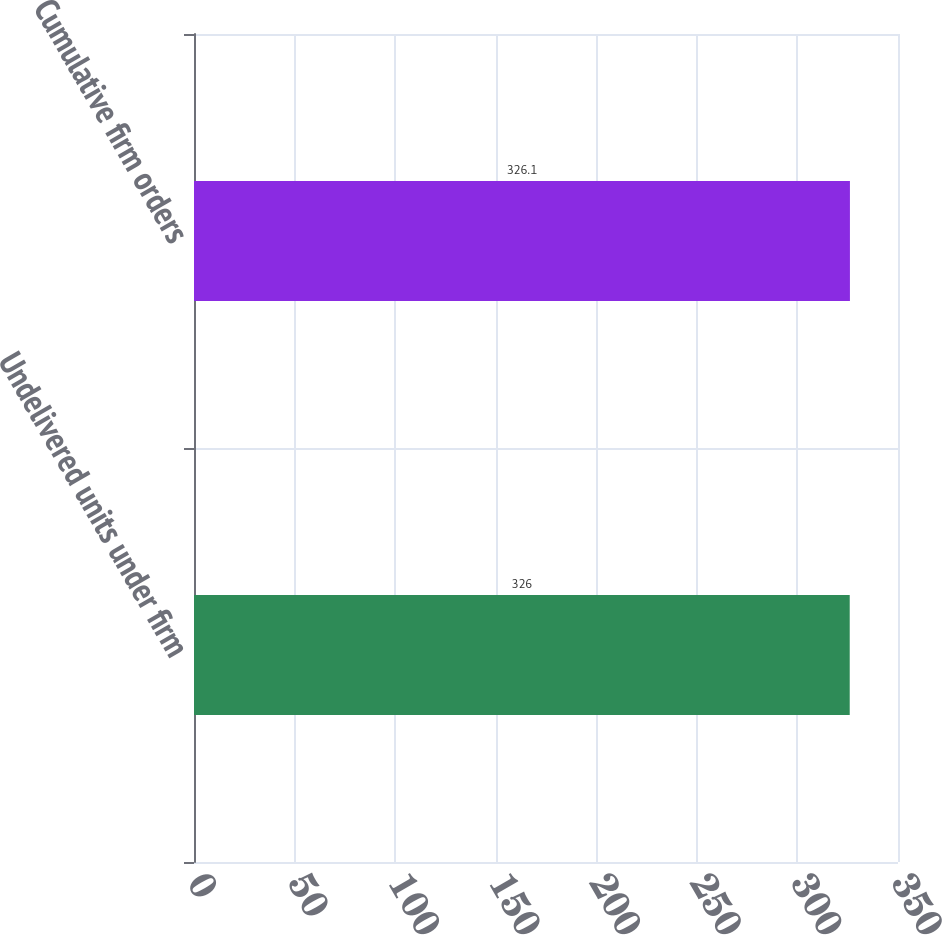<chart> <loc_0><loc_0><loc_500><loc_500><bar_chart><fcel>Undelivered units under firm<fcel>Cumulative firm orders<nl><fcel>326<fcel>326.1<nl></chart> 